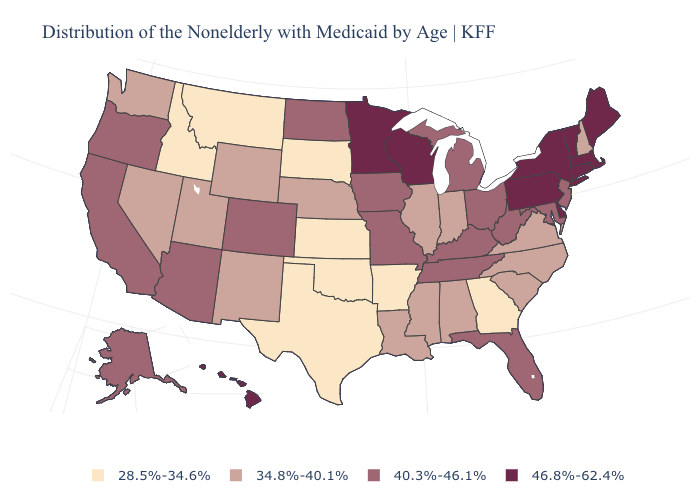How many symbols are there in the legend?
Answer briefly. 4. What is the value of Arkansas?
Quick response, please. 28.5%-34.6%. What is the highest value in states that border Indiana?
Quick response, please. 40.3%-46.1%. Name the states that have a value in the range 34.8%-40.1%?
Give a very brief answer. Alabama, Illinois, Indiana, Louisiana, Mississippi, Nebraska, Nevada, New Hampshire, New Mexico, North Carolina, South Carolina, Utah, Virginia, Washington, Wyoming. Name the states that have a value in the range 40.3%-46.1%?
Short answer required. Alaska, Arizona, California, Colorado, Florida, Iowa, Kentucky, Maryland, Michigan, Missouri, New Jersey, North Dakota, Ohio, Oregon, Tennessee, West Virginia. What is the value of Maryland?
Write a very short answer. 40.3%-46.1%. Name the states that have a value in the range 46.8%-62.4%?
Quick response, please. Connecticut, Delaware, Hawaii, Maine, Massachusetts, Minnesota, New York, Pennsylvania, Rhode Island, Vermont, Wisconsin. Does the first symbol in the legend represent the smallest category?
Answer briefly. Yes. Which states have the highest value in the USA?
Write a very short answer. Connecticut, Delaware, Hawaii, Maine, Massachusetts, Minnesota, New York, Pennsylvania, Rhode Island, Vermont, Wisconsin. What is the highest value in states that border West Virginia?
Give a very brief answer. 46.8%-62.4%. Name the states that have a value in the range 28.5%-34.6%?
Be succinct. Arkansas, Georgia, Idaho, Kansas, Montana, Oklahoma, South Dakota, Texas. Does New Jersey have the highest value in the Northeast?
Be succinct. No. What is the lowest value in the MidWest?
Keep it brief. 28.5%-34.6%. Among the states that border Kentucky , which have the lowest value?
Concise answer only. Illinois, Indiana, Virginia. What is the value of Michigan?
Keep it brief. 40.3%-46.1%. 